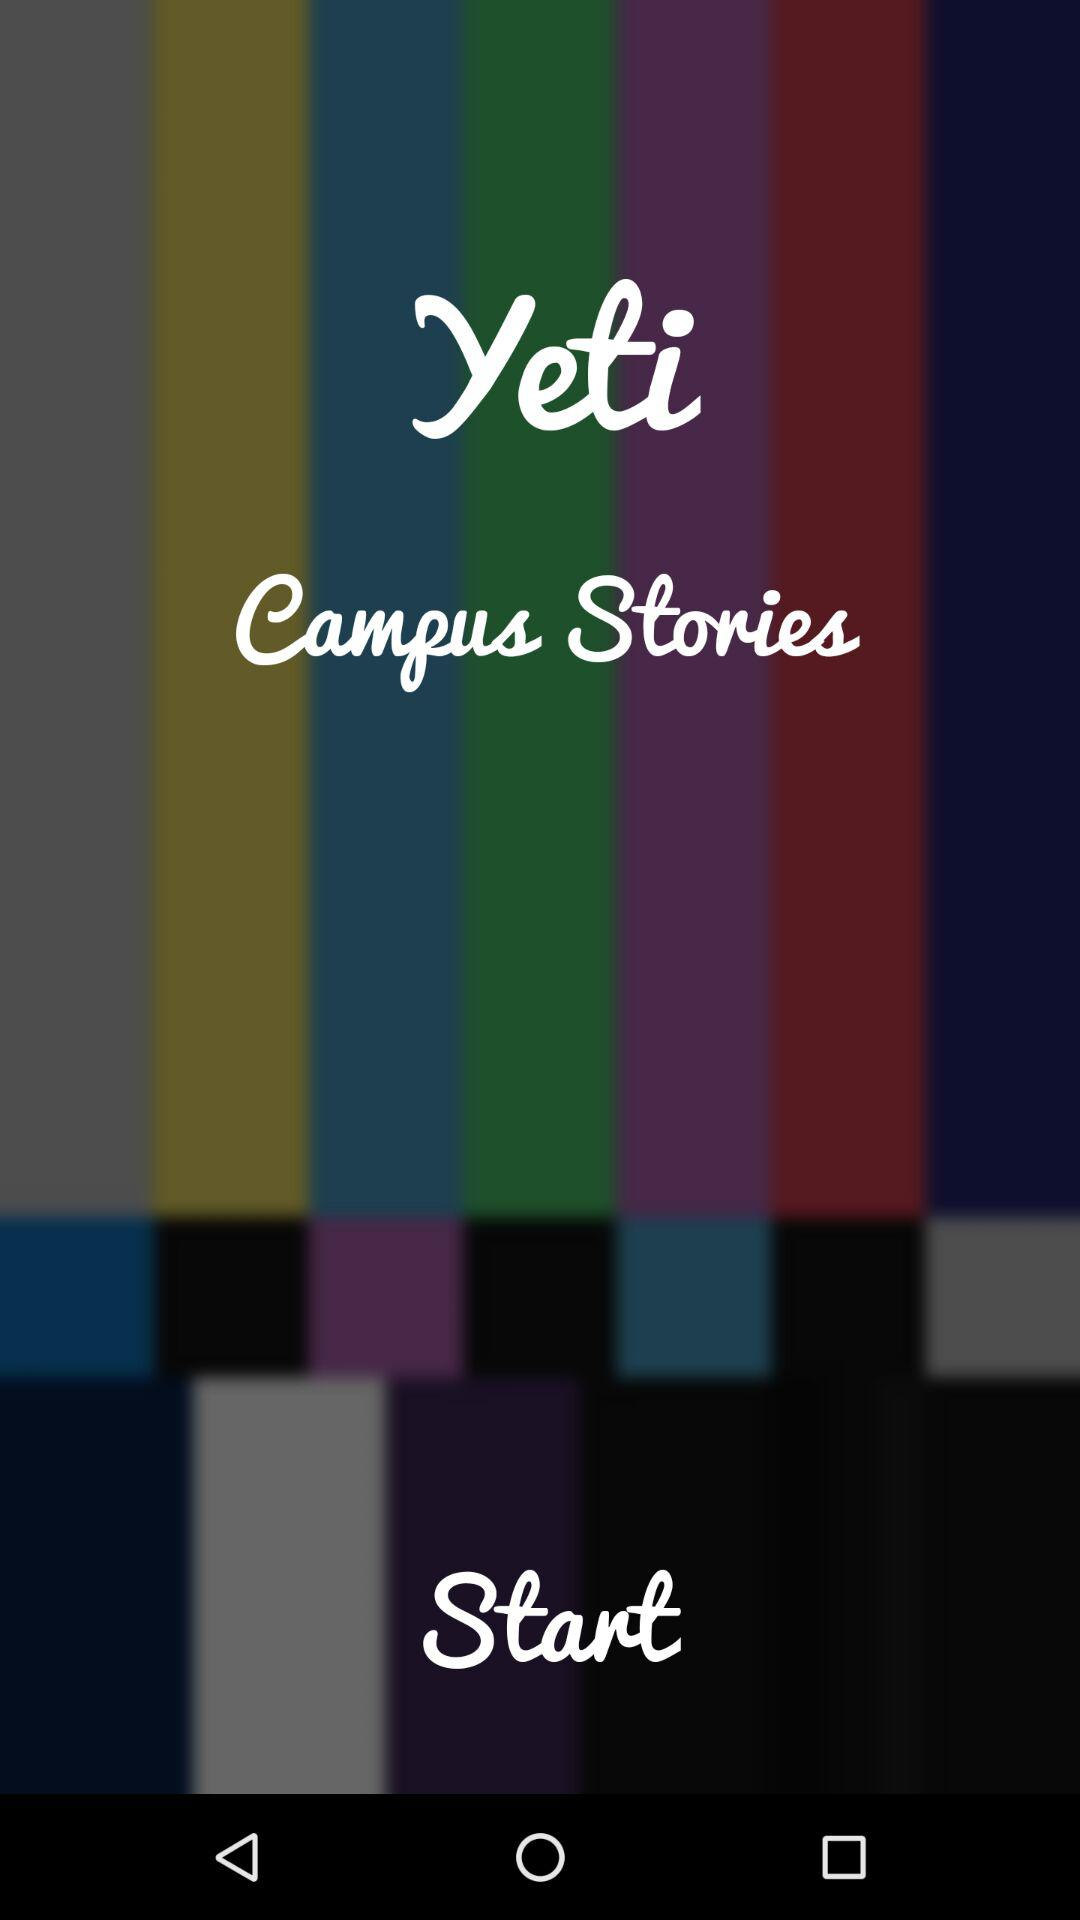What is the application name? The application name is "Yeti Campus Stories". 